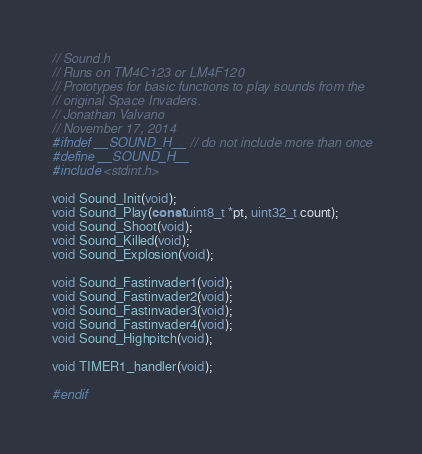<code> <loc_0><loc_0><loc_500><loc_500><_C_>// Sound.h
// Runs on TM4C123 or LM4F120
// Prototypes for basic functions to play sounds from the
// original Space Invaders.
// Jonathan Valvano
// November 17, 2014
#ifndef __SOUND_H__ // do not include more than once
#define __SOUND_H__
#include <stdint.h>

void Sound_Init(void);
void Sound_Play(const uint8_t *pt, uint32_t count);
void Sound_Shoot(void);
void Sound_Killed(void);
void Sound_Explosion(void);

void Sound_Fastinvader1(void);
void Sound_Fastinvader2(void);
void Sound_Fastinvader3(void);
void Sound_Fastinvader4(void);
void Sound_Highpitch(void);

void TIMER1_handler(void);

#endif


</code> 